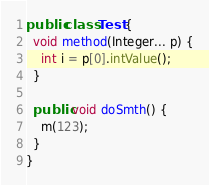<code> <loc_0><loc_0><loc_500><loc_500><_Java_>public class Test {
  void method(Integer... p) {
    int i = p[0].intValue();
  }

  public void doSmth() {
    m(123);
  }
}
</code> 